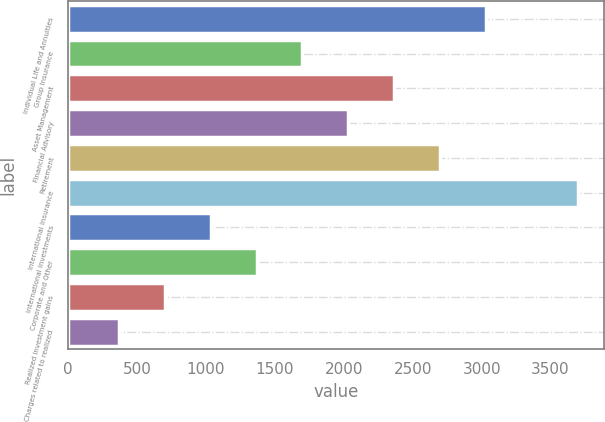Convert chart. <chart><loc_0><loc_0><loc_500><loc_500><bar_chart><fcel>Individual Life and Annuities<fcel>Group Insurance<fcel>Asset Management<fcel>Financial Advisory<fcel>Retirement<fcel>International Insurance<fcel>International Investments<fcel>Corporate and Other<fcel>Realized investment gains<fcel>Charges related to realized<nl><fcel>3034.5<fcel>1700.5<fcel>2367.5<fcel>2034<fcel>2701<fcel>3701.5<fcel>1033.5<fcel>1367<fcel>700<fcel>366.5<nl></chart> 